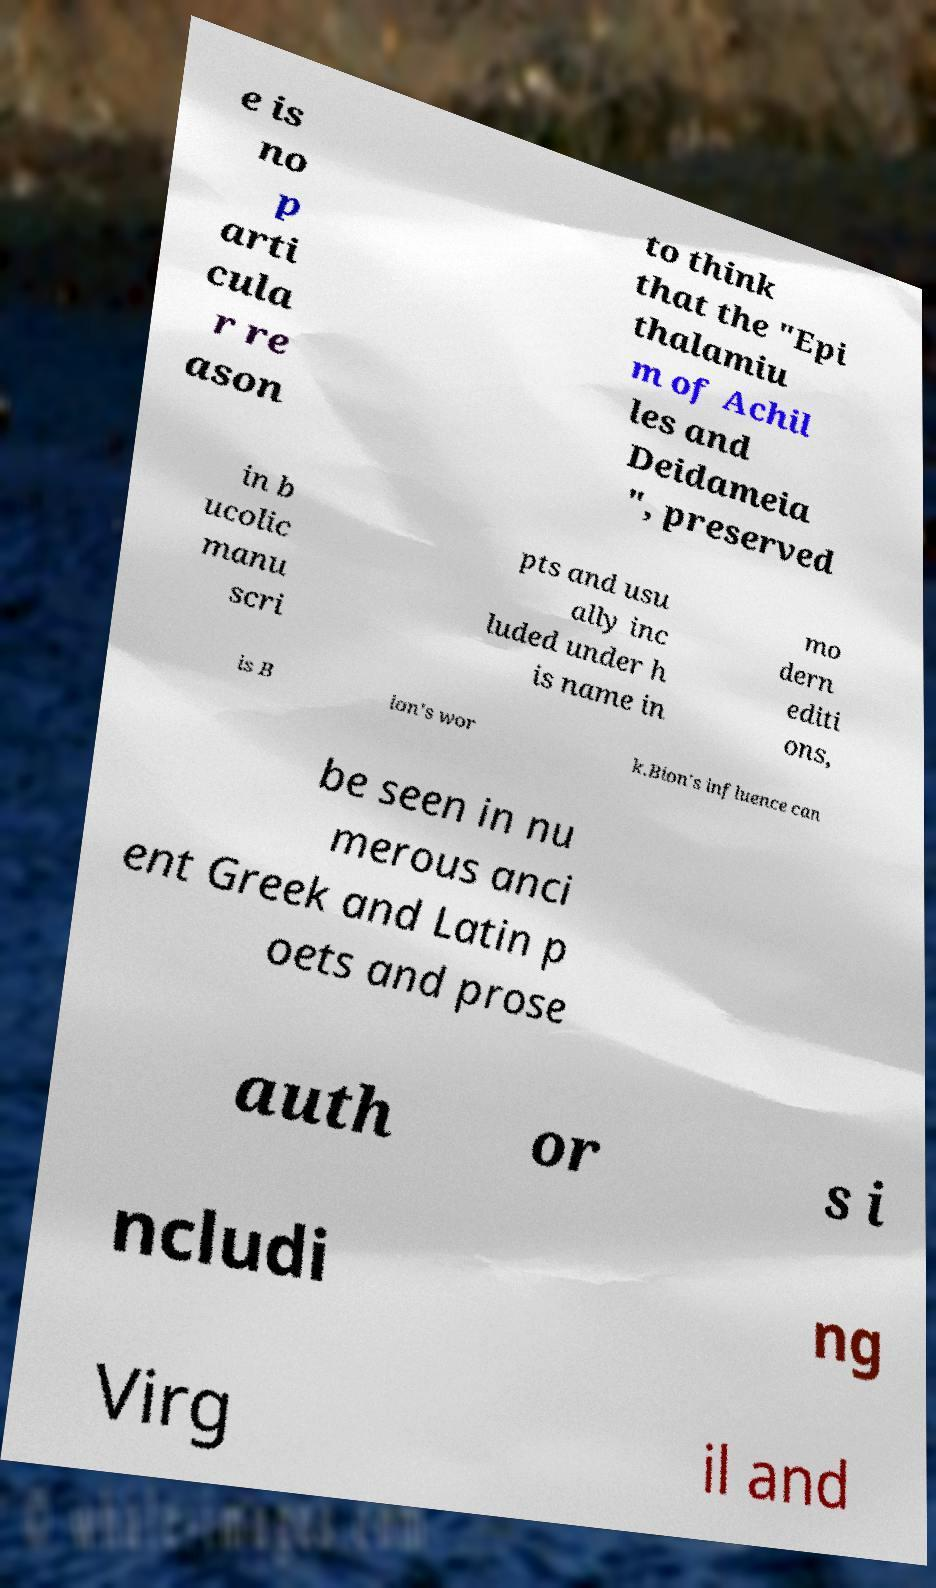For documentation purposes, I need the text within this image transcribed. Could you provide that? e is no p arti cula r re ason to think that the "Epi thalamiu m of Achil les and Deidameia ", preserved in b ucolic manu scri pts and usu ally inc luded under h is name in mo dern editi ons, is B ion's wor k.Bion's influence can be seen in nu merous anci ent Greek and Latin p oets and prose auth or s i ncludi ng Virg il and 